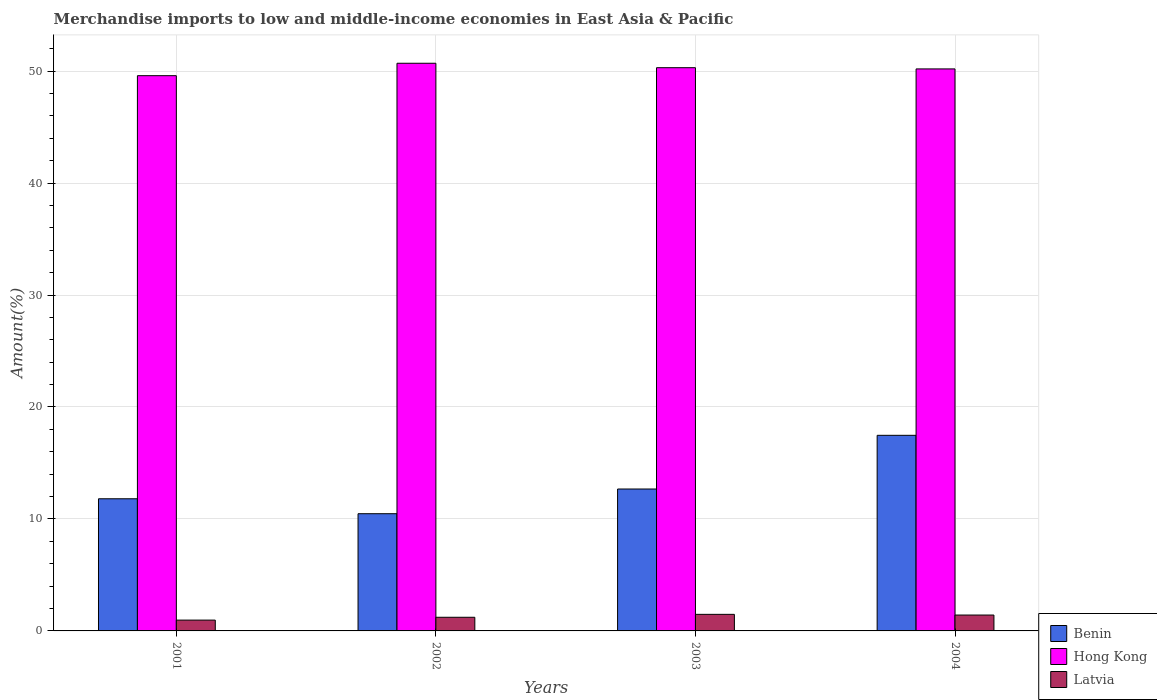How many different coloured bars are there?
Give a very brief answer. 3. How many groups of bars are there?
Keep it short and to the point. 4. Are the number of bars on each tick of the X-axis equal?
Your response must be concise. Yes. How many bars are there on the 4th tick from the left?
Provide a short and direct response. 3. In how many cases, is the number of bars for a given year not equal to the number of legend labels?
Give a very brief answer. 0. What is the percentage of amount earned from merchandise imports in Benin in 2001?
Provide a succinct answer. 11.8. Across all years, what is the maximum percentage of amount earned from merchandise imports in Hong Kong?
Offer a very short reply. 50.7. Across all years, what is the minimum percentage of amount earned from merchandise imports in Hong Kong?
Give a very brief answer. 49.59. What is the total percentage of amount earned from merchandise imports in Benin in the graph?
Your answer should be compact. 52.41. What is the difference between the percentage of amount earned from merchandise imports in Benin in 2001 and that in 2004?
Make the answer very short. -5.67. What is the difference between the percentage of amount earned from merchandise imports in Latvia in 2003 and the percentage of amount earned from merchandise imports in Hong Kong in 2001?
Ensure brevity in your answer.  -48.11. What is the average percentage of amount earned from merchandise imports in Hong Kong per year?
Offer a terse response. 50.2. In the year 2003, what is the difference between the percentage of amount earned from merchandise imports in Latvia and percentage of amount earned from merchandise imports in Hong Kong?
Keep it short and to the point. -48.82. What is the ratio of the percentage of amount earned from merchandise imports in Benin in 2001 to that in 2003?
Your response must be concise. 0.93. Is the percentage of amount earned from merchandise imports in Hong Kong in 2001 less than that in 2002?
Provide a short and direct response. Yes. Is the difference between the percentage of amount earned from merchandise imports in Latvia in 2001 and 2002 greater than the difference between the percentage of amount earned from merchandise imports in Hong Kong in 2001 and 2002?
Give a very brief answer. Yes. What is the difference between the highest and the second highest percentage of amount earned from merchandise imports in Latvia?
Provide a short and direct response. 0.06. What is the difference between the highest and the lowest percentage of amount earned from merchandise imports in Benin?
Ensure brevity in your answer.  7. Is the sum of the percentage of amount earned from merchandise imports in Benin in 2002 and 2004 greater than the maximum percentage of amount earned from merchandise imports in Latvia across all years?
Offer a very short reply. Yes. What does the 2nd bar from the left in 2002 represents?
Your answer should be very brief. Hong Kong. What does the 3rd bar from the right in 2001 represents?
Offer a terse response. Benin. Is it the case that in every year, the sum of the percentage of amount earned from merchandise imports in Hong Kong and percentage of amount earned from merchandise imports in Benin is greater than the percentage of amount earned from merchandise imports in Latvia?
Provide a succinct answer. Yes. How many years are there in the graph?
Provide a succinct answer. 4. Are the values on the major ticks of Y-axis written in scientific E-notation?
Your response must be concise. No. Does the graph contain any zero values?
Offer a very short reply. No. Where does the legend appear in the graph?
Make the answer very short. Bottom right. How many legend labels are there?
Provide a short and direct response. 3. What is the title of the graph?
Give a very brief answer. Merchandise imports to low and middle-income economies in East Asia & Pacific. Does "Macao" appear as one of the legend labels in the graph?
Your answer should be compact. No. What is the label or title of the X-axis?
Offer a terse response. Years. What is the label or title of the Y-axis?
Your response must be concise. Amount(%). What is the Amount(%) in Benin in 2001?
Keep it short and to the point. 11.8. What is the Amount(%) of Hong Kong in 2001?
Provide a short and direct response. 49.59. What is the Amount(%) in Latvia in 2001?
Provide a short and direct response. 0.97. What is the Amount(%) of Benin in 2002?
Provide a succinct answer. 10.47. What is the Amount(%) of Hong Kong in 2002?
Make the answer very short. 50.7. What is the Amount(%) of Latvia in 2002?
Your answer should be compact. 1.22. What is the Amount(%) of Benin in 2003?
Ensure brevity in your answer.  12.67. What is the Amount(%) of Hong Kong in 2003?
Keep it short and to the point. 50.3. What is the Amount(%) in Latvia in 2003?
Ensure brevity in your answer.  1.48. What is the Amount(%) in Benin in 2004?
Provide a short and direct response. 17.47. What is the Amount(%) in Hong Kong in 2004?
Offer a terse response. 50.19. What is the Amount(%) of Latvia in 2004?
Ensure brevity in your answer.  1.42. Across all years, what is the maximum Amount(%) in Benin?
Provide a short and direct response. 17.47. Across all years, what is the maximum Amount(%) of Hong Kong?
Your answer should be very brief. 50.7. Across all years, what is the maximum Amount(%) of Latvia?
Your answer should be very brief. 1.48. Across all years, what is the minimum Amount(%) of Benin?
Your response must be concise. 10.47. Across all years, what is the minimum Amount(%) in Hong Kong?
Ensure brevity in your answer.  49.59. Across all years, what is the minimum Amount(%) of Latvia?
Your answer should be very brief. 0.97. What is the total Amount(%) in Benin in the graph?
Make the answer very short. 52.41. What is the total Amount(%) in Hong Kong in the graph?
Keep it short and to the point. 200.79. What is the total Amount(%) of Latvia in the graph?
Give a very brief answer. 5.08. What is the difference between the Amount(%) of Benin in 2001 and that in 2002?
Your response must be concise. 1.33. What is the difference between the Amount(%) in Hong Kong in 2001 and that in 2002?
Make the answer very short. -1.11. What is the difference between the Amount(%) of Latvia in 2001 and that in 2002?
Give a very brief answer. -0.25. What is the difference between the Amount(%) of Benin in 2001 and that in 2003?
Your answer should be compact. -0.87. What is the difference between the Amount(%) in Hong Kong in 2001 and that in 2003?
Your answer should be very brief. -0.71. What is the difference between the Amount(%) of Latvia in 2001 and that in 2003?
Offer a very short reply. -0.51. What is the difference between the Amount(%) of Benin in 2001 and that in 2004?
Your answer should be very brief. -5.67. What is the difference between the Amount(%) in Hong Kong in 2001 and that in 2004?
Your response must be concise. -0.6. What is the difference between the Amount(%) of Latvia in 2001 and that in 2004?
Give a very brief answer. -0.45. What is the difference between the Amount(%) of Benin in 2002 and that in 2003?
Make the answer very short. -2.21. What is the difference between the Amount(%) in Hong Kong in 2002 and that in 2003?
Provide a succinct answer. 0.4. What is the difference between the Amount(%) of Latvia in 2002 and that in 2003?
Provide a short and direct response. -0.26. What is the difference between the Amount(%) of Benin in 2002 and that in 2004?
Offer a terse response. -7. What is the difference between the Amount(%) in Hong Kong in 2002 and that in 2004?
Keep it short and to the point. 0.51. What is the difference between the Amount(%) of Latvia in 2002 and that in 2004?
Your answer should be compact. -0.2. What is the difference between the Amount(%) of Benin in 2003 and that in 2004?
Your answer should be very brief. -4.8. What is the difference between the Amount(%) in Hong Kong in 2003 and that in 2004?
Your response must be concise. 0.11. What is the difference between the Amount(%) of Latvia in 2003 and that in 2004?
Offer a very short reply. 0.06. What is the difference between the Amount(%) of Benin in 2001 and the Amount(%) of Hong Kong in 2002?
Provide a succinct answer. -38.9. What is the difference between the Amount(%) of Benin in 2001 and the Amount(%) of Latvia in 2002?
Your answer should be compact. 10.58. What is the difference between the Amount(%) of Hong Kong in 2001 and the Amount(%) of Latvia in 2002?
Your answer should be compact. 48.37. What is the difference between the Amount(%) in Benin in 2001 and the Amount(%) in Hong Kong in 2003?
Offer a terse response. -38.5. What is the difference between the Amount(%) of Benin in 2001 and the Amount(%) of Latvia in 2003?
Offer a very short reply. 10.32. What is the difference between the Amount(%) in Hong Kong in 2001 and the Amount(%) in Latvia in 2003?
Your response must be concise. 48.11. What is the difference between the Amount(%) in Benin in 2001 and the Amount(%) in Hong Kong in 2004?
Provide a succinct answer. -38.39. What is the difference between the Amount(%) of Benin in 2001 and the Amount(%) of Latvia in 2004?
Ensure brevity in your answer.  10.38. What is the difference between the Amount(%) in Hong Kong in 2001 and the Amount(%) in Latvia in 2004?
Give a very brief answer. 48.17. What is the difference between the Amount(%) in Benin in 2002 and the Amount(%) in Hong Kong in 2003?
Make the answer very short. -39.83. What is the difference between the Amount(%) of Benin in 2002 and the Amount(%) of Latvia in 2003?
Offer a terse response. 8.99. What is the difference between the Amount(%) in Hong Kong in 2002 and the Amount(%) in Latvia in 2003?
Your answer should be very brief. 49.22. What is the difference between the Amount(%) of Benin in 2002 and the Amount(%) of Hong Kong in 2004?
Your response must be concise. -39.73. What is the difference between the Amount(%) of Benin in 2002 and the Amount(%) of Latvia in 2004?
Give a very brief answer. 9.05. What is the difference between the Amount(%) in Hong Kong in 2002 and the Amount(%) in Latvia in 2004?
Offer a terse response. 49.28. What is the difference between the Amount(%) of Benin in 2003 and the Amount(%) of Hong Kong in 2004?
Give a very brief answer. -37.52. What is the difference between the Amount(%) of Benin in 2003 and the Amount(%) of Latvia in 2004?
Ensure brevity in your answer.  11.26. What is the difference between the Amount(%) in Hong Kong in 2003 and the Amount(%) in Latvia in 2004?
Your answer should be very brief. 48.88. What is the average Amount(%) in Benin per year?
Your response must be concise. 13.1. What is the average Amount(%) in Hong Kong per year?
Give a very brief answer. 50.2. What is the average Amount(%) in Latvia per year?
Ensure brevity in your answer.  1.27. In the year 2001, what is the difference between the Amount(%) of Benin and Amount(%) of Hong Kong?
Give a very brief answer. -37.79. In the year 2001, what is the difference between the Amount(%) of Benin and Amount(%) of Latvia?
Provide a succinct answer. 10.84. In the year 2001, what is the difference between the Amount(%) in Hong Kong and Amount(%) in Latvia?
Offer a very short reply. 48.62. In the year 2002, what is the difference between the Amount(%) of Benin and Amount(%) of Hong Kong?
Ensure brevity in your answer.  -40.23. In the year 2002, what is the difference between the Amount(%) in Benin and Amount(%) in Latvia?
Your answer should be very brief. 9.25. In the year 2002, what is the difference between the Amount(%) in Hong Kong and Amount(%) in Latvia?
Give a very brief answer. 49.48. In the year 2003, what is the difference between the Amount(%) of Benin and Amount(%) of Hong Kong?
Your response must be concise. -37.63. In the year 2003, what is the difference between the Amount(%) in Benin and Amount(%) in Latvia?
Offer a very short reply. 11.19. In the year 2003, what is the difference between the Amount(%) in Hong Kong and Amount(%) in Latvia?
Your answer should be compact. 48.82. In the year 2004, what is the difference between the Amount(%) of Benin and Amount(%) of Hong Kong?
Keep it short and to the point. -32.72. In the year 2004, what is the difference between the Amount(%) of Benin and Amount(%) of Latvia?
Keep it short and to the point. 16.05. In the year 2004, what is the difference between the Amount(%) in Hong Kong and Amount(%) in Latvia?
Provide a succinct answer. 48.78. What is the ratio of the Amount(%) of Benin in 2001 to that in 2002?
Provide a succinct answer. 1.13. What is the ratio of the Amount(%) of Hong Kong in 2001 to that in 2002?
Make the answer very short. 0.98. What is the ratio of the Amount(%) of Latvia in 2001 to that in 2002?
Provide a short and direct response. 0.79. What is the ratio of the Amount(%) of Benin in 2001 to that in 2003?
Provide a short and direct response. 0.93. What is the ratio of the Amount(%) in Hong Kong in 2001 to that in 2003?
Your response must be concise. 0.99. What is the ratio of the Amount(%) of Latvia in 2001 to that in 2003?
Give a very brief answer. 0.65. What is the ratio of the Amount(%) in Benin in 2001 to that in 2004?
Offer a very short reply. 0.68. What is the ratio of the Amount(%) of Hong Kong in 2001 to that in 2004?
Your answer should be very brief. 0.99. What is the ratio of the Amount(%) in Latvia in 2001 to that in 2004?
Your response must be concise. 0.68. What is the ratio of the Amount(%) in Benin in 2002 to that in 2003?
Your answer should be compact. 0.83. What is the ratio of the Amount(%) of Hong Kong in 2002 to that in 2003?
Offer a terse response. 1.01. What is the ratio of the Amount(%) of Latvia in 2002 to that in 2003?
Ensure brevity in your answer.  0.82. What is the ratio of the Amount(%) in Benin in 2002 to that in 2004?
Give a very brief answer. 0.6. What is the ratio of the Amount(%) of Latvia in 2002 to that in 2004?
Your answer should be very brief. 0.86. What is the ratio of the Amount(%) in Benin in 2003 to that in 2004?
Your answer should be very brief. 0.73. What is the ratio of the Amount(%) of Hong Kong in 2003 to that in 2004?
Offer a very short reply. 1. What is the ratio of the Amount(%) in Latvia in 2003 to that in 2004?
Offer a very short reply. 1.04. What is the difference between the highest and the second highest Amount(%) in Benin?
Provide a succinct answer. 4.8. What is the difference between the highest and the second highest Amount(%) in Hong Kong?
Your answer should be compact. 0.4. What is the difference between the highest and the second highest Amount(%) of Latvia?
Provide a short and direct response. 0.06. What is the difference between the highest and the lowest Amount(%) of Benin?
Make the answer very short. 7. What is the difference between the highest and the lowest Amount(%) of Hong Kong?
Keep it short and to the point. 1.11. What is the difference between the highest and the lowest Amount(%) of Latvia?
Give a very brief answer. 0.51. 